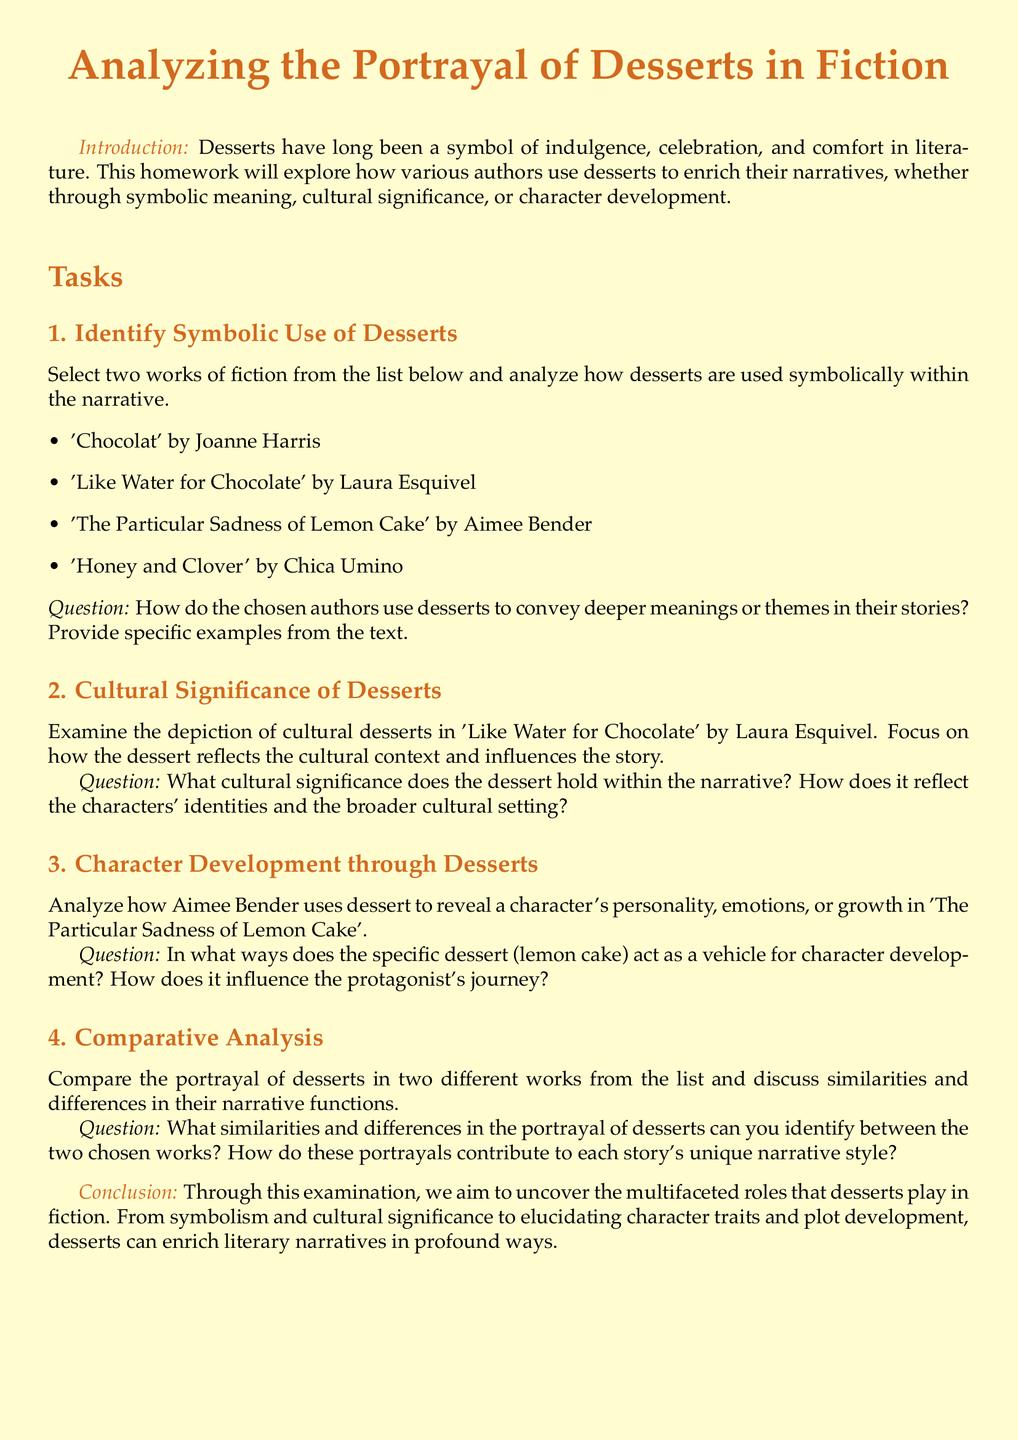what is the title of the homework? The title of the homework is prominently displayed at the top of the document.
Answer: Analyzing the Portrayal of Desserts in Fiction who is the author of 'Chocolat'? The document lists 'Chocolat' as a work by Joanne Harris.
Answer: Joanne Harris how many tasks are included in the homework? The document outlines a total of four tasks for the homework assignment.
Answer: 4 which dessert is analyzed for cultural significance in the second task? The second task specifically examines the dessert associated with 'Like Water for Chocolate'.
Answer: cultural desserts what is the focus of the third task? The third task requires analysis of how dessert reveals character personality and growth in a specific work.
Answer: character development through desserts what themes are suggested to be conveyed through desserts in the narrative? The introduction implies that desserts symbolize indulgence, celebration, and comfort in literature.
Answer: indulgence, celebration, comfort which two works are compared in the fourth task? The fourth task does not specify which two works should be compared, allowing for choice among those listed.
Answer: any two works from the list how does the document conclude? The conclusion in the document summarises the examination's aims regarding desserts' roles in fiction.
Answer: uncover the multifaceted roles of desserts 